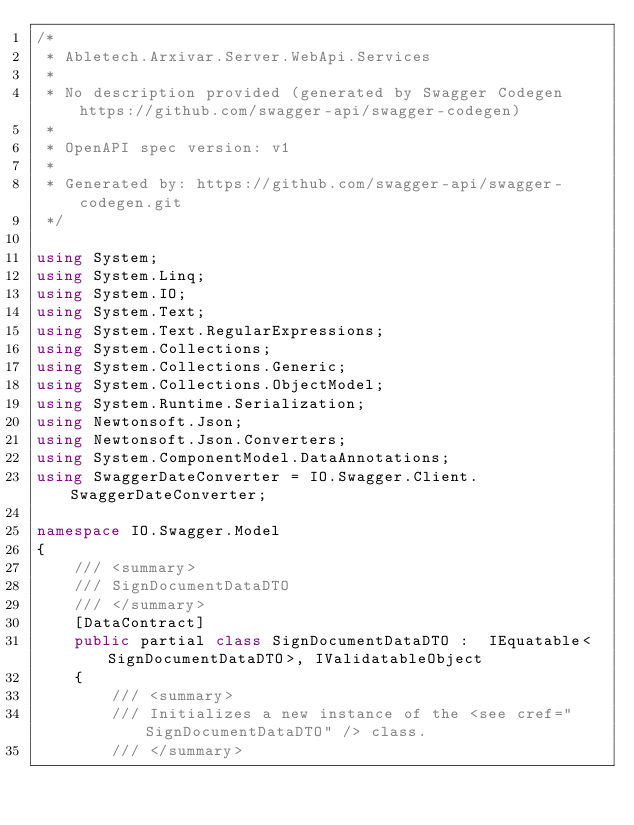<code> <loc_0><loc_0><loc_500><loc_500><_C#_>/* 
 * Abletech.Arxivar.Server.WebApi.Services
 *
 * No description provided (generated by Swagger Codegen https://github.com/swagger-api/swagger-codegen)
 *
 * OpenAPI spec version: v1
 * 
 * Generated by: https://github.com/swagger-api/swagger-codegen.git
 */

using System;
using System.Linq;
using System.IO;
using System.Text;
using System.Text.RegularExpressions;
using System.Collections;
using System.Collections.Generic;
using System.Collections.ObjectModel;
using System.Runtime.Serialization;
using Newtonsoft.Json;
using Newtonsoft.Json.Converters;
using System.ComponentModel.DataAnnotations;
using SwaggerDateConverter = IO.Swagger.Client.SwaggerDateConverter;

namespace IO.Swagger.Model
{
    /// <summary>
    /// SignDocumentDataDTO
    /// </summary>
    [DataContract]
    public partial class SignDocumentDataDTO :  IEquatable<SignDocumentDataDTO>, IValidatableObject
    {
        /// <summary>
        /// Initializes a new instance of the <see cref="SignDocumentDataDTO" /> class.
        /// </summary></code> 